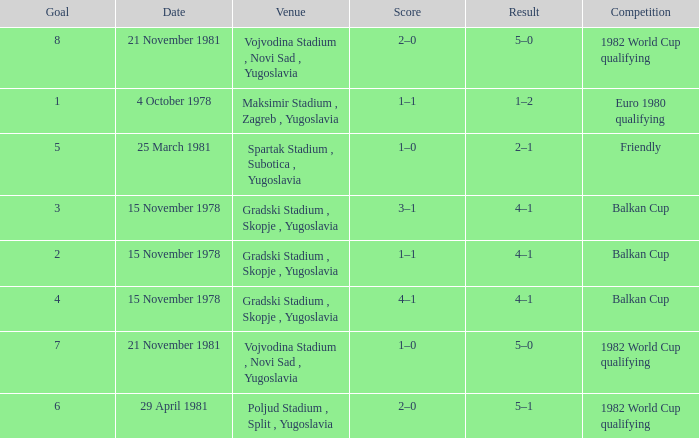What is the effect for target 3? 4–1. 